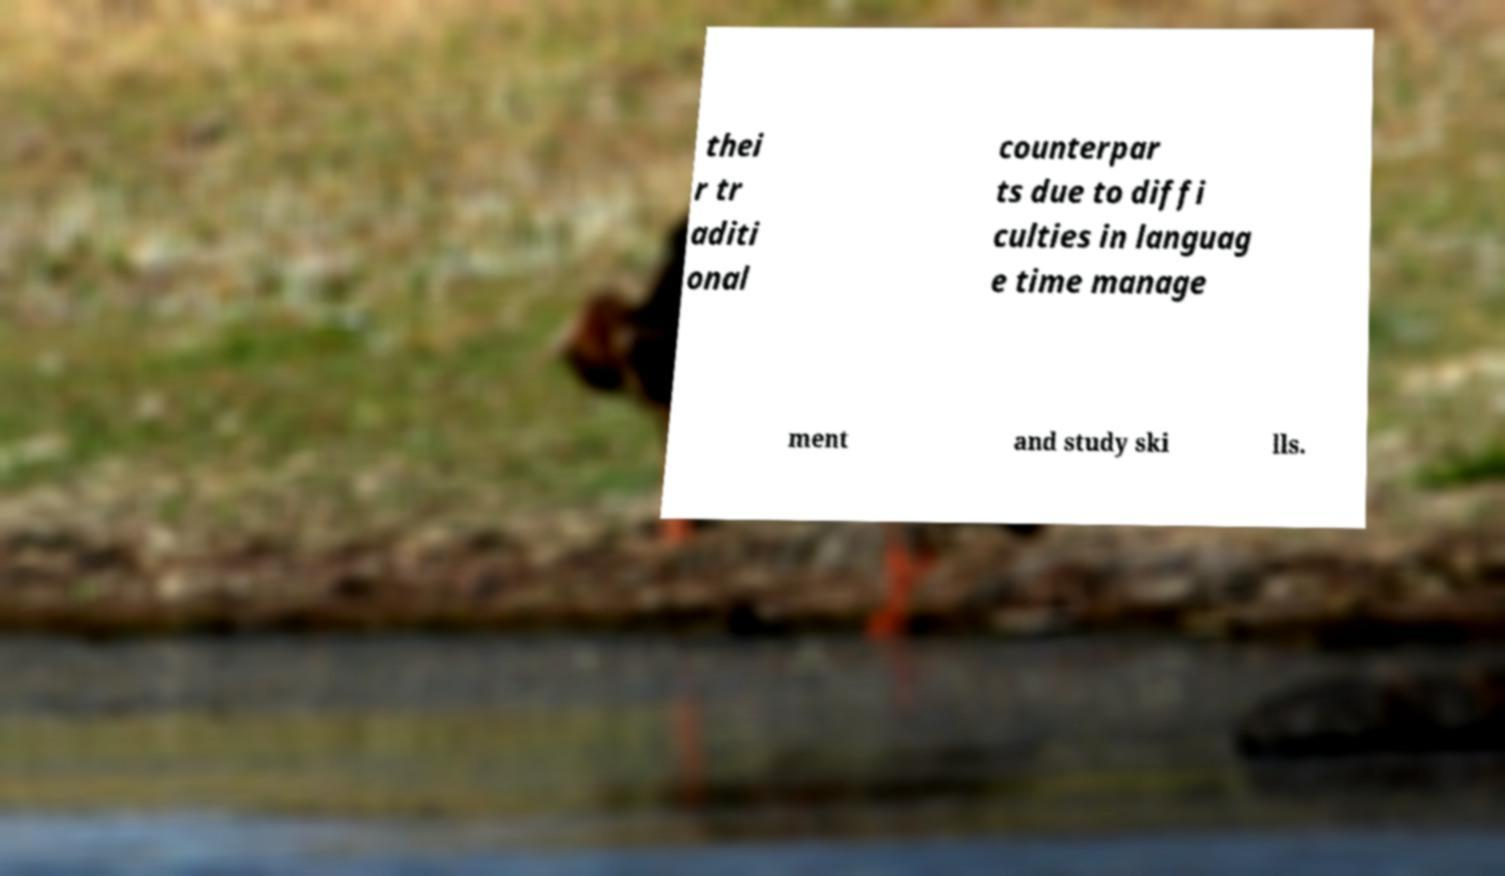What messages or text are displayed in this image? I need them in a readable, typed format. thei r tr aditi onal counterpar ts due to diffi culties in languag e time manage ment and study ski lls. 